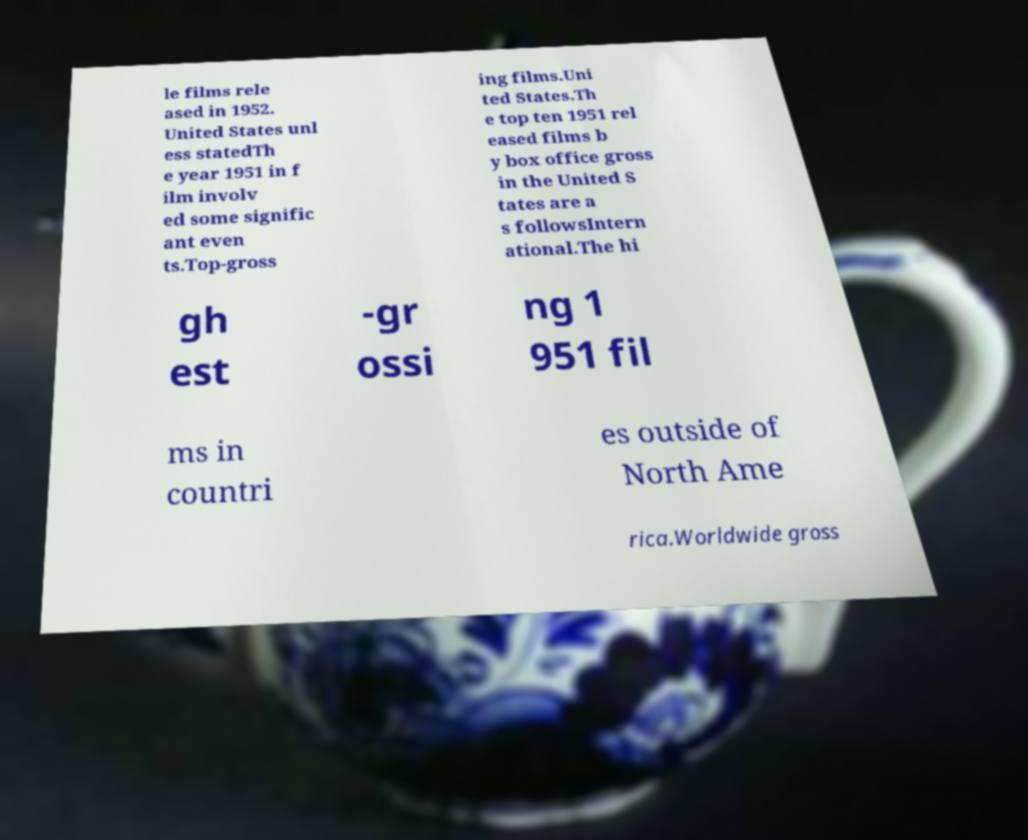I need the written content from this picture converted into text. Can you do that? le films rele ased in 1952. United States unl ess statedTh e year 1951 in f ilm involv ed some signific ant even ts.Top-gross ing films.Uni ted States.Th e top ten 1951 rel eased films b y box office gross in the United S tates are a s followsIntern ational.The hi gh est -gr ossi ng 1 951 fil ms in countri es outside of North Ame rica.Worldwide gross 